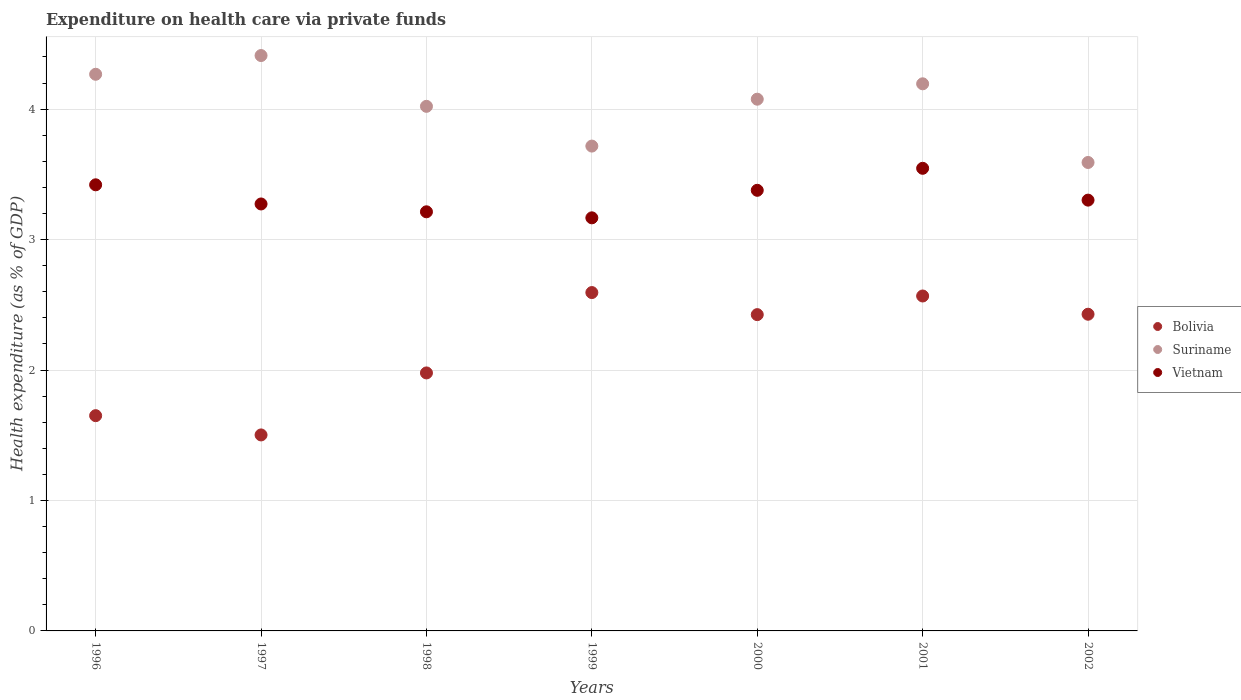How many different coloured dotlines are there?
Your response must be concise. 3. What is the expenditure made on health care in Suriname in 1999?
Your answer should be compact. 3.72. Across all years, what is the maximum expenditure made on health care in Vietnam?
Give a very brief answer. 3.55. Across all years, what is the minimum expenditure made on health care in Vietnam?
Give a very brief answer. 3.17. What is the total expenditure made on health care in Suriname in the graph?
Provide a succinct answer. 28.28. What is the difference between the expenditure made on health care in Vietnam in 1999 and that in 2000?
Offer a very short reply. -0.21. What is the difference between the expenditure made on health care in Vietnam in 2002 and the expenditure made on health care in Bolivia in 2001?
Ensure brevity in your answer.  0.73. What is the average expenditure made on health care in Suriname per year?
Provide a short and direct response. 4.04. In the year 2002, what is the difference between the expenditure made on health care in Bolivia and expenditure made on health care in Suriname?
Make the answer very short. -1.16. What is the ratio of the expenditure made on health care in Suriname in 2000 to that in 2001?
Make the answer very short. 0.97. Is the difference between the expenditure made on health care in Bolivia in 1996 and 2000 greater than the difference between the expenditure made on health care in Suriname in 1996 and 2000?
Your answer should be compact. No. What is the difference between the highest and the second highest expenditure made on health care in Bolivia?
Offer a very short reply. 0.03. What is the difference between the highest and the lowest expenditure made on health care in Bolivia?
Your answer should be very brief. 1.09. Is the sum of the expenditure made on health care in Bolivia in 2000 and 2001 greater than the maximum expenditure made on health care in Vietnam across all years?
Your answer should be compact. Yes. Does the expenditure made on health care in Suriname monotonically increase over the years?
Keep it short and to the point. No. How many dotlines are there?
Give a very brief answer. 3. How many years are there in the graph?
Give a very brief answer. 7. How are the legend labels stacked?
Ensure brevity in your answer.  Vertical. What is the title of the graph?
Provide a succinct answer. Expenditure on health care via private funds. What is the label or title of the Y-axis?
Your answer should be very brief. Health expenditure (as % of GDP). What is the Health expenditure (as % of GDP) in Bolivia in 1996?
Your answer should be compact. 1.65. What is the Health expenditure (as % of GDP) of Suriname in 1996?
Keep it short and to the point. 4.27. What is the Health expenditure (as % of GDP) in Vietnam in 1996?
Your answer should be very brief. 3.42. What is the Health expenditure (as % of GDP) of Bolivia in 1997?
Keep it short and to the point. 1.5. What is the Health expenditure (as % of GDP) of Suriname in 1997?
Offer a very short reply. 4.41. What is the Health expenditure (as % of GDP) of Vietnam in 1997?
Your answer should be compact. 3.27. What is the Health expenditure (as % of GDP) of Bolivia in 1998?
Your response must be concise. 1.98. What is the Health expenditure (as % of GDP) of Suriname in 1998?
Your answer should be very brief. 4.02. What is the Health expenditure (as % of GDP) in Vietnam in 1998?
Your response must be concise. 3.21. What is the Health expenditure (as % of GDP) of Bolivia in 1999?
Provide a succinct answer. 2.59. What is the Health expenditure (as % of GDP) of Suriname in 1999?
Ensure brevity in your answer.  3.72. What is the Health expenditure (as % of GDP) of Vietnam in 1999?
Give a very brief answer. 3.17. What is the Health expenditure (as % of GDP) in Bolivia in 2000?
Offer a very short reply. 2.42. What is the Health expenditure (as % of GDP) of Suriname in 2000?
Your answer should be compact. 4.08. What is the Health expenditure (as % of GDP) of Vietnam in 2000?
Make the answer very short. 3.38. What is the Health expenditure (as % of GDP) of Bolivia in 2001?
Offer a terse response. 2.57. What is the Health expenditure (as % of GDP) in Suriname in 2001?
Ensure brevity in your answer.  4.19. What is the Health expenditure (as % of GDP) in Vietnam in 2001?
Your answer should be compact. 3.55. What is the Health expenditure (as % of GDP) of Bolivia in 2002?
Your answer should be very brief. 2.43. What is the Health expenditure (as % of GDP) in Suriname in 2002?
Make the answer very short. 3.59. What is the Health expenditure (as % of GDP) of Vietnam in 2002?
Provide a succinct answer. 3.3. Across all years, what is the maximum Health expenditure (as % of GDP) in Bolivia?
Offer a very short reply. 2.59. Across all years, what is the maximum Health expenditure (as % of GDP) of Suriname?
Make the answer very short. 4.41. Across all years, what is the maximum Health expenditure (as % of GDP) of Vietnam?
Your response must be concise. 3.55. Across all years, what is the minimum Health expenditure (as % of GDP) of Bolivia?
Provide a succinct answer. 1.5. Across all years, what is the minimum Health expenditure (as % of GDP) of Suriname?
Provide a succinct answer. 3.59. Across all years, what is the minimum Health expenditure (as % of GDP) of Vietnam?
Your answer should be compact. 3.17. What is the total Health expenditure (as % of GDP) in Bolivia in the graph?
Keep it short and to the point. 15.14. What is the total Health expenditure (as % of GDP) in Suriname in the graph?
Offer a terse response. 28.28. What is the total Health expenditure (as % of GDP) in Vietnam in the graph?
Your answer should be compact. 23.3. What is the difference between the Health expenditure (as % of GDP) in Bolivia in 1996 and that in 1997?
Your answer should be very brief. 0.15. What is the difference between the Health expenditure (as % of GDP) in Suriname in 1996 and that in 1997?
Offer a terse response. -0.14. What is the difference between the Health expenditure (as % of GDP) of Vietnam in 1996 and that in 1997?
Your answer should be very brief. 0.15. What is the difference between the Health expenditure (as % of GDP) of Bolivia in 1996 and that in 1998?
Your answer should be very brief. -0.33. What is the difference between the Health expenditure (as % of GDP) of Suriname in 1996 and that in 1998?
Ensure brevity in your answer.  0.25. What is the difference between the Health expenditure (as % of GDP) of Vietnam in 1996 and that in 1998?
Ensure brevity in your answer.  0.21. What is the difference between the Health expenditure (as % of GDP) of Bolivia in 1996 and that in 1999?
Provide a short and direct response. -0.94. What is the difference between the Health expenditure (as % of GDP) in Suriname in 1996 and that in 1999?
Offer a very short reply. 0.55. What is the difference between the Health expenditure (as % of GDP) of Vietnam in 1996 and that in 1999?
Your answer should be compact. 0.25. What is the difference between the Health expenditure (as % of GDP) in Bolivia in 1996 and that in 2000?
Your response must be concise. -0.77. What is the difference between the Health expenditure (as % of GDP) of Suriname in 1996 and that in 2000?
Your response must be concise. 0.19. What is the difference between the Health expenditure (as % of GDP) in Vietnam in 1996 and that in 2000?
Make the answer very short. 0.04. What is the difference between the Health expenditure (as % of GDP) of Bolivia in 1996 and that in 2001?
Provide a succinct answer. -0.92. What is the difference between the Health expenditure (as % of GDP) in Suriname in 1996 and that in 2001?
Offer a terse response. 0.07. What is the difference between the Health expenditure (as % of GDP) of Vietnam in 1996 and that in 2001?
Provide a short and direct response. -0.13. What is the difference between the Health expenditure (as % of GDP) in Bolivia in 1996 and that in 2002?
Provide a short and direct response. -0.78. What is the difference between the Health expenditure (as % of GDP) of Suriname in 1996 and that in 2002?
Your response must be concise. 0.68. What is the difference between the Health expenditure (as % of GDP) of Vietnam in 1996 and that in 2002?
Keep it short and to the point. 0.12. What is the difference between the Health expenditure (as % of GDP) in Bolivia in 1997 and that in 1998?
Make the answer very short. -0.48. What is the difference between the Health expenditure (as % of GDP) of Suriname in 1997 and that in 1998?
Offer a terse response. 0.39. What is the difference between the Health expenditure (as % of GDP) in Vietnam in 1997 and that in 1998?
Offer a very short reply. 0.06. What is the difference between the Health expenditure (as % of GDP) of Bolivia in 1997 and that in 1999?
Provide a short and direct response. -1.09. What is the difference between the Health expenditure (as % of GDP) in Suriname in 1997 and that in 1999?
Provide a short and direct response. 0.69. What is the difference between the Health expenditure (as % of GDP) of Vietnam in 1997 and that in 1999?
Your response must be concise. 0.11. What is the difference between the Health expenditure (as % of GDP) of Bolivia in 1997 and that in 2000?
Your response must be concise. -0.92. What is the difference between the Health expenditure (as % of GDP) of Suriname in 1997 and that in 2000?
Ensure brevity in your answer.  0.33. What is the difference between the Health expenditure (as % of GDP) in Vietnam in 1997 and that in 2000?
Your response must be concise. -0.1. What is the difference between the Health expenditure (as % of GDP) of Bolivia in 1997 and that in 2001?
Your response must be concise. -1.07. What is the difference between the Health expenditure (as % of GDP) of Suriname in 1997 and that in 2001?
Give a very brief answer. 0.22. What is the difference between the Health expenditure (as % of GDP) of Vietnam in 1997 and that in 2001?
Your answer should be compact. -0.27. What is the difference between the Health expenditure (as % of GDP) of Bolivia in 1997 and that in 2002?
Ensure brevity in your answer.  -0.93. What is the difference between the Health expenditure (as % of GDP) of Suriname in 1997 and that in 2002?
Your answer should be compact. 0.82. What is the difference between the Health expenditure (as % of GDP) of Vietnam in 1997 and that in 2002?
Your answer should be compact. -0.03. What is the difference between the Health expenditure (as % of GDP) of Bolivia in 1998 and that in 1999?
Keep it short and to the point. -0.62. What is the difference between the Health expenditure (as % of GDP) of Suriname in 1998 and that in 1999?
Give a very brief answer. 0.3. What is the difference between the Health expenditure (as % of GDP) in Vietnam in 1998 and that in 1999?
Ensure brevity in your answer.  0.05. What is the difference between the Health expenditure (as % of GDP) in Bolivia in 1998 and that in 2000?
Offer a terse response. -0.45. What is the difference between the Health expenditure (as % of GDP) in Suriname in 1998 and that in 2000?
Ensure brevity in your answer.  -0.05. What is the difference between the Health expenditure (as % of GDP) in Vietnam in 1998 and that in 2000?
Provide a succinct answer. -0.16. What is the difference between the Health expenditure (as % of GDP) in Bolivia in 1998 and that in 2001?
Give a very brief answer. -0.59. What is the difference between the Health expenditure (as % of GDP) in Suriname in 1998 and that in 2001?
Provide a short and direct response. -0.17. What is the difference between the Health expenditure (as % of GDP) of Vietnam in 1998 and that in 2001?
Provide a short and direct response. -0.33. What is the difference between the Health expenditure (as % of GDP) of Bolivia in 1998 and that in 2002?
Your answer should be very brief. -0.45. What is the difference between the Health expenditure (as % of GDP) of Suriname in 1998 and that in 2002?
Provide a succinct answer. 0.43. What is the difference between the Health expenditure (as % of GDP) in Vietnam in 1998 and that in 2002?
Offer a very short reply. -0.09. What is the difference between the Health expenditure (as % of GDP) of Bolivia in 1999 and that in 2000?
Your response must be concise. 0.17. What is the difference between the Health expenditure (as % of GDP) in Suriname in 1999 and that in 2000?
Offer a very short reply. -0.36. What is the difference between the Health expenditure (as % of GDP) in Vietnam in 1999 and that in 2000?
Your response must be concise. -0.21. What is the difference between the Health expenditure (as % of GDP) in Bolivia in 1999 and that in 2001?
Give a very brief answer. 0.03. What is the difference between the Health expenditure (as % of GDP) of Suriname in 1999 and that in 2001?
Provide a short and direct response. -0.48. What is the difference between the Health expenditure (as % of GDP) in Vietnam in 1999 and that in 2001?
Provide a succinct answer. -0.38. What is the difference between the Health expenditure (as % of GDP) of Bolivia in 1999 and that in 2002?
Ensure brevity in your answer.  0.17. What is the difference between the Health expenditure (as % of GDP) in Suriname in 1999 and that in 2002?
Ensure brevity in your answer.  0.13. What is the difference between the Health expenditure (as % of GDP) in Vietnam in 1999 and that in 2002?
Provide a succinct answer. -0.14. What is the difference between the Health expenditure (as % of GDP) of Bolivia in 2000 and that in 2001?
Your answer should be compact. -0.14. What is the difference between the Health expenditure (as % of GDP) of Suriname in 2000 and that in 2001?
Your answer should be very brief. -0.12. What is the difference between the Health expenditure (as % of GDP) of Vietnam in 2000 and that in 2001?
Provide a succinct answer. -0.17. What is the difference between the Health expenditure (as % of GDP) in Bolivia in 2000 and that in 2002?
Provide a short and direct response. -0. What is the difference between the Health expenditure (as % of GDP) in Suriname in 2000 and that in 2002?
Your answer should be compact. 0.49. What is the difference between the Health expenditure (as % of GDP) of Vietnam in 2000 and that in 2002?
Provide a short and direct response. 0.08. What is the difference between the Health expenditure (as % of GDP) in Bolivia in 2001 and that in 2002?
Give a very brief answer. 0.14. What is the difference between the Health expenditure (as % of GDP) in Suriname in 2001 and that in 2002?
Your response must be concise. 0.6. What is the difference between the Health expenditure (as % of GDP) of Vietnam in 2001 and that in 2002?
Make the answer very short. 0.24. What is the difference between the Health expenditure (as % of GDP) in Bolivia in 1996 and the Health expenditure (as % of GDP) in Suriname in 1997?
Your answer should be compact. -2.76. What is the difference between the Health expenditure (as % of GDP) in Bolivia in 1996 and the Health expenditure (as % of GDP) in Vietnam in 1997?
Ensure brevity in your answer.  -1.62. What is the difference between the Health expenditure (as % of GDP) of Suriname in 1996 and the Health expenditure (as % of GDP) of Vietnam in 1997?
Provide a succinct answer. 0.99. What is the difference between the Health expenditure (as % of GDP) in Bolivia in 1996 and the Health expenditure (as % of GDP) in Suriname in 1998?
Make the answer very short. -2.37. What is the difference between the Health expenditure (as % of GDP) in Bolivia in 1996 and the Health expenditure (as % of GDP) in Vietnam in 1998?
Keep it short and to the point. -1.56. What is the difference between the Health expenditure (as % of GDP) of Suriname in 1996 and the Health expenditure (as % of GDP) of Vietnam in 1998?
Make the answer very short. 1.05. What is the difference between the Health expenditure (as % of GDP) of Bolivia in 1996 and the Health expenditure (as % of GDP) of Suriname in 1999?
Your response must be concise. -2.07. What is the difference between the Health expenditure (as % of GDP) in Bolivia in 1996 and the Health expenditure (as % of GDP) in Vietnam in 1999?
Make the answer very short. -1.52. What is the difference between the Health expenditure (as % of GDP) of Suriname in 1996 and the Health expenditure (as % of GDP) of Vietnam in 1999?
Your answer should be very brief. 1.1. What is the difference between the Health expenditure (as % of GDP) of Bolivia in 1996 and the Health expenditure (as % of GDP) of Suriname in 2000?
Your response must be concise. -2.43. What is the difference between the Health expenditure (as % of GDP) in Bolivia in 1996 and the Health expenditure (as % of GDP) in Vietnam in 2000?
Provide a succinct answer. -1.73. What is the difference between the Health expenditure (as % of GDP) in Suriname in 1996 and the Health expenditure (as % of GDP) in Vietnam in 2000?
Give a very brief answer. 0.89. What is the difference between the Health expenditure (as % of GDP) in Bolivia in 1996 and the Health expenditure (as % of GDP) in Suriname in 2001?
Provide a succinct answer. -2.54. What is the difference between the Health expenditure (as % of GDP) of Bolivia in 1996 and the Health expenditure (as % of GDP) of Vietnam in 2001?
Ensure brevity in your answer.  -1.9. What is the difference between the Health expenditure (as % of GDP) of Suriname in 1996 and the Health expenditure (as % of GDP) of Vietnam in 2001?
Your response must be concise. 0.72. What is the difference between the Health expenditure (as % of GDP) of Bolivia in 1996 and the Health expenditure (as % of GDP) of Suriname in 2002?
Ensure brevity in your answer.  -1.94. What is the difference between the Health expenditure (as % of GDP) of Bolivia in 1996 and the Health expenditure (as % of GDP) of Vietnam in 2002?
Your response must be concise. -1.65. What is the difference between the Health expenditure (as % of GDP) of Suriname in 1996 and the Health expenditure (as % of GDP) of Vietnam in 2002?
Offer a terse response. 0.96. What is the difference between the Health expenditure (as % of GDP) of Bolivia in 1997 and the Health expenditure (as % of GDP) of Suriname in 1998?
Provide a succinct answer. -2.52. What is the difference between the Health expenditure (as % of GDP) in Bolivia in 1997 and the Health expenditure (as % of GDP) in Vietnam in 1998?
Give a very brief answer. -1.71. What is the difference between the Health expenditure (as % of GDP) of Suriname in 1997 and the Health expenditure (as % of GDP) of Vietnam in 1998?
Keep it short and to the point. 1.2. What is the difference between the Health expenditure (as % of GDP) in Bolivia in 1997 and the Health expenditure (as % of GDP) in Suriname in 1999?
Offer a very short reply. -2.21. What is the difference between the Health expenditure (as % of GDP) of Bolivia in 1997 and the Health expenditure (as % of GDP) of Vietnam in 1999?
Provide a short and direct response. -1.66. What is the difference between the Health expenditure (as % of GDP) of Suriname in 1997 and the Health expenditure (as % of GDP) of Vietnam in 1999?
Your answer should be compact. 1.24. What is the difference between the Health expenditure (as % of GDP) in Bolivia in 1997 and the Health expenditure (as % of GDP) in Suriname in 2000?
Your answer should be very brief. -2.57. What is the difference between the Health expenditure (as % of GDP) in Bolivia in 1997 and the Health expenditure (as % of GDP) in Vietnam in 2000?
Your answer should be compact. -1.88. What is the difference between the Health expenditure (as % of GDP) in Suriname in 1997 and the Health expenditure (as % of GDP) in Vietnam in 2000?
Your answer should be compact. 1.03. What is the difference between the Health expenditure (as % of GDP) in Bolivia in 1997 and the Health expenditure (as % of GDP) in Suriname in 2001?
Provide a succinct answer. -2.69. What is the difference between the Health expenditure (as % of GDP) of Bolivia in 1997 and the Health expenditure (as % of GDP) of Vietnam in 2001?
Provide a short and direct response. -2.04. What is the difference between the Health expenditure (as % of GDP) in Suriname in 1997 and the Health expenditure (as % of GDP) in Vietnam in 2001?
Offer a terse response. 0.86. What is the difference between the Health expenditure (as % of GDP) of Bolivia in 1997 and the Health expenditure (as % of GDP) of Suriname in 2002?
Give a very brief answer. -2.09. What is the difference between the Health expenditure (as % of GDP) in Bolivia in 1997 and the Health expenditure (as % of GDP) in Vietnam in 2002?
Your answer should be very brief. -1.8. What is the difference between the Health expenditure (as % of GDP) of Suriname in 1997 and the Health expenditure (as % of GDP) of Vietnam in 2002?
Keep it short and to the point. 1.11. What is the difference between the Health expenditure (as % of GDP) in Bolivia in 1998 and the Health expenditure (as % of GDP) in Suriname in 1999?
Offer a very short reply. -1.74. What is the difference between the Health expenditure (as % of GDP) in Bolivia in 1998 and the Health expenditure (as % of GDP) in Vietnam in 1999?
Your response must be concise. -1.19. What is the difference between the Health expenditure (as % of GDP) in Suriname in 1998 and the Health expenditure (as % of GDP) in Vietnam in 1999?
Ensure brevity in your answer.  0.85. What is the difference between the Health expenditure (as % of GDP) of Bolivia in 1998 and the Health expenditure (as % of GDP) of Suriname in 2000?
Make the answer very short. -2.1. What is the difference between the Health expenditure (as % of GDP) of Bolivia in 1998 and the Health expenditure (as % of GDP) of Vietnam in 2000?
Keep it short and to the point. -1.4. What is the difference between the Health expenditure (as % of GDP) in Suriname in 1998 and the Health expenditure (as % of GDP) in Vietnam in 2000?
Your response must be concise. 0.64. What is the difference between the Health expenditure (as % of GDP) of Bolivia in 1998 and the Health expenditure (as % of GDP) of Suriname in 2001?
Keep it short and to the point. -2.22. What is the difference between the Health expenditure (as % of GDP) of Bolivia in 1998 and the Health expenditure (as % of GDP) of Vietnam in 2001?
Provide a short and direct response. -1.57. What is the difference between the Health expenditure (as % of GDP) of Suriname in 1998 and the Health expenditure (as % of GDP) of Vietnam in 2001?
Your response must be concise. 0.48. What is the difference between the Health expenditure (as % of GDP) of Bolivia in 1998 and the Health expenditure (as % of GDP) of Suriname in 2002?
Ensure brevity in your answer.  -1.61. What is the difference between the Health expenditure (as % of GDP) in Bolivia in 1998 and the Health expenditure (as % of GDP) in Vietnam in 2002?
Provide a succinct answer. -1.32. What is the difference between the Health expenditure (as % of GDP) of Suriname in 1998 and the Health expenditure (as % of GDP) of Vietnam in 2002?
Offer a very short reply. 0.72. What is the difference between the Health expenditure (as % of GDP) in Bolivia in 1999 and the Health expenditure (as % of GDP) in Suriname in 2000?
Your answer should be compact. -1.48. What is the difference between the Health expenditure (as % of GDP) of Bolivia in 1999 and the Health expenditure (as % of GDP) of Vietnam in 2000?
Give a very brief answer. -0.78. What is the difference between the Health expenditure (as % of GDP) in Suriname in 1999 and the Health expenditure (as % of GDP) in Vietnam in 2000?
Your answer should be compact. 0.34. What is the difference between the Health expenditure (as % of GDP) in Bolivia in 1999 and the Health expenditure (as % of GDP) in Suriname in 2001?
Give a very brief answer. -1.6. What is the difference between the Health expenditure (as % of GDP) of Bolivia in 1999 and the Health expenditure (as % of GDP) of Vietnam in 2001?
Offer a terse response. -0.95. What is the difference between the Health expenditure (as % of GDP) of Suriname in 1999 and the Health expenditure (as % of GDP) of Vietnam in 2001?
Make the answer very short. 0.17. What is the difference between the Health expenditure (as % of GDP) in Bolivia in 1999 and the Health expenditure (as % of GDP) in Suriname in 2002?
Give a very brief answer. -1. What is the difference between the Health expenditure (as % of GDP) of Bolivia in 1999 and the Health expenditure (as % of GDP) of Vietnam in 2002?
Offer a very short reply. -0.71. What is the difference between the Health expenditure (as % of GDP) of Suriname in 1999 and the Health expenditure (as % of GDP) of Vietnam in 2002?
Your answer should be very brief. 0.41. What is the difference between the Health expenditure (as % of GDP) in Bolivia in 2000 and the Health expenditure (as % of GDP) in Suriname in 2001?
Keep it short and to the point. -1.77. What is the difference between the Health expenditure (as % of GDP) of Bolivia in 2000 and the Health expenditure (as % of GDP) of Vietnam in 2001?
Your response must be concise. -1.12. What is the difference between the Health expenditure (as % of GDP) in Suriname in 2000 and the Health expenditure (as % of GDP) in Vietnam in 2001?
Your response must be concise. 0.53. What is the difference between the Health expenditure (as % of GDP) of Bolivia in 2000 and the Health expenditure (as % of GDP) of Suriname in 2002?
Your response must be concise. -1.17. What is the difference between the Health expenditure (as % of GDP) in Bolivia in 2000 and the Health expenditure (as % of GDP) in Vietnam in 2002?
Offer a terse response. -0.88. What is the difference between the Health expenditure (as % of GDP) of Suriname in 2000 and the Health expenditure (as % of GDP) of Vietnam in 2002?
Give a very brief answer. 0.77. What is the difference between the Health expenditure (as % of GDP) of Bolivia in 2001 and the Health expenditure (as % of GDP) of Suriname in 2002?
Your response must be concise. -1.02. What is the difference between the Health expenditure (as % of GDP) of Bolivia in 2001 and the Health expenditure (as % of GDP) of Vietnam in 2002?
Ensure brevity in your answer.  -0.73. What is the difference between the Health expenditure (as % of GDP) of Suriname in 2001 and the Health expenditure (as % of GDP) of Vietnam in 2002?
Your answer should be very brief. 0.89. What is the average Health expenditure (as % of GDP) of Bolivia per year?
Your answer should be very brief. 2.16. What is the average Health expenditure (as % of GDP) in Suriname per year?
Your answer should be compact. 4.04. What is the average Health expenditure (as % of GDP) in Vietnam per year?
Provide a succinct answer. 3.33. In the year 1996, what is the difference between the Health expenditure (as % of GDP) of Bolivia and Health expenditure (as % of GDP) of Suriname?
Provide a succinct answer. -2.62. In the year 1996, what is the difference between the Health expenditure (as % of GDP) of Bolivia and Health expenditure (as % of GDP) of Vietnam?
Offer a terse response. -1.77. In the year 1996, what is the difference between the Health expenditure (as % of GDP) in Suriname and Health expenditure (as % of GDP) in Vietnam?
Ensure brevity in your answer.  0.85. In the year 1997, what is the difference between the Health expenditure (as % of GDP) of Bolivia and Health expenditure (as % of GDP) of Suriname?
Make the answer very short. -2.91. In the year 1997, what is the difference between the Health expenditure (as % of GDP) in Bolivia and Health expenditure (as % of GDP) in Vietnam?
Give a very brief answer. -1.77. In the year 1997, what is the difference between the Health expenditure (as % of GDP) in Suriname and Health expenditure (as % of GDP) in Vietnam?
Give a very brief answer. 1.14. In the year 1998, what is the difference between the Health expenditure (as % of GDP) in Bolivia and Health expenditure (as % of GDP) in Suriname?
Ensure brevity in your answer.  -2.04. In the year 1998, what is the difference between the Health expenditure (as % of GDP) of Bolivia and Health expenditure (as % of GDP) of Vietnam?
Provide a succinct answer. -1.24. In the year 1998, what is the difference between the Health expenditure (as % of GDP) of Suriname and Health expenditure (as % of GDP) of Vietnam?
Offer a terse response. 0.81. In the year 1999, what is the difference between the Health expenditure (as % of GDP) in Bolivia and Health expenditure (as % of GDP) in Suriname?
Offer a terse response. -1.12. In the year 1999, what is the difference between the Health expenditure (as % of GDP) in Bolivia and Health expenditure (as % of GDP) in Vietnam?
Your answer should be compact. -0.57. In the year 1999, what is the difference between the Health expenditure (as % of GDP) in Suriname and Health expenditure (as % of GDP) in Vietnam?
Offer a very short reply. 0.55. In the year 2000, what is the difference between the Health expenditure (as % of GDP) in Bolivia and Health expenditure (as % of GDP) in Suriname?
Ensure brevity in your answer.  -1.65. In the year 2000, what is the difference between the Health expenditure (as % of GDP) in Bolivia and Health expenditure (as % of GDP) in Vietnam?
Provide a short and direct response. -0.95. In the year 2000, what is the difference between the Health expenditure (as % of GDP) in Suriname and Health expenditure (as % of GDP) in Vietnam?
Provide a short and direct response. 0.7. In the year 2001, what is the difference between the Health expenditure (as % of GDP) of Bolivia and Health expenditure (as % of GDP) of Suriname?
Offer a very short reply. -1.63. In the year 2001, what is the difference between the Health expenditure (as % of GDP) in Bolivia and Health expenditure (as % of GDP) in Vietnam?
Your response must be concise. -0.98. In the year 2001, what is the difference between the Health expenditure (as % of GDP) of Suriname and Health expenditure (as % of GDP) of Vietnam?
Your answer should be compact. 0.65. In the year 2002, what is the difference between the Health expenditure (as % of GDP) in Bolivia and Health expenditure (as % of GDP) in Suriname?
Ensure brevity in your answer.  -1.16. In the year 2002, what is the difference between the Health expenditure (as % of GDP) in Bolivia and Health expenditure (as % of GDP) in Vietnam?
Offer a terse response. -0.87. In the year 2002, what is the difference between the Health expenditure (as % of GDP) of Suriname and Health expenditure (as % of GDP) of Vietnam?
Your answer should be very brief. 0.29. What is the ratio of the Health expenditure (as % of GDP) in Bolivia in 1996 to that in 1997?
Provide a succinct answer. 1.1. What is the ratio of the Health expenditure (as % of GDP) in Suriname in 1996 to that in 1997?
Offer a very short reply. 0.97. What is the ratio of the Health expenditure (as % of GDP) of Vietnam in 1996 to that in 1997?
Provide a short and direct response. 1.04. What is the ratio of the Health expenditure (as % of GDP) of Bolivia in 1996 to that in 1998?
Give a very brief answer. 0.83. What is the ratio of the Health expenditure (as % of GDP) of Suriname in 1996 to that in 1998?
Keep it short and to the point. 1.06. What is the ratio of the Health expenditure (as % of GDP) of Vietnam in 1996 to that in 1998?
Your answer should be compact. 1.06. What is the ratio of the Health expenditure (as % of GDP) in Bolivia in 1996 to that in 1999?
Ensure brevity in your answer.  0.64. What is the ratio of the Health expenditure (as % of GDP) of Suriname in 1996 to that in 1999?
Offer a terse response. 1.15. What is the ratio of the Health expenditure (as % of GDP) in Vietnam in 1996 to that in 1999?
Your answer should be compact. 1.08. What is the ratio of the Health expenditure (as % of GDP) of Bolivia in 1996 to that in 2000?
Provide a short and direct response. 0.68. What is the ratio of the Health expenditure (as % of GDP) of Suriname in 1996 to that in 2000?
Give a very brief answer. 1.05. What is the ratio of the Health expenditure (as % of GDP) of Vietnam in 1996 to that in 2000?
Your response must be concise. 1.01. What is the ratio of the Health expenditure (as % of GDP) of Bolivia in 1996 to that in 2001?
Provide a succinct answer. 0.64. What is the ratio of the Health expenditure (as % of GDP) of Suriname in 1996 to that in 2001?
Offer a very short reply. 1.02. What is the ratio of the Health expenditure (as % of GDP) in Bolivia in 1996 to that in 2002?
Provide a succinct answer. 0.68. What is the ratio of the Health expenditure (as % of GDP) in Suriname in 1996 to that in 2002?
Keep it short and to the point. 1.19. What is the ratio of the Health expenditure (as % of GDP) of Vietnam in 1996 to that in 2002?
Your response must be concise. 1.04. What is the ratio of the Health expenditure (as % of GDP) of Bolivia in 1997 to that in 1998?
Provide a short and direct response. 0.76. What is the ratio of the Health expenditure (as % of GDP) in Suriname in 1997 to that in 1998?
Make the answer very short. 1.1. What is the ratio of the Health expenditure (as % of GDP) of Vietnam in 1997 to that in 1998?
Give a very brief answer. 1.02. What is the ratio of the Health expenditure (as % of GDP) of Bolivia in 1997 to that in 1999?
Offer a terse response. 0.58. What is the ratio of the Health expenditure (as % of GDP) of Suriname in 1997 to that in 1999?
Offer a very short reply. 1.19. What is the ratio of the Health expenditure (as % of GDP) in Vietnam in 1997 to that in 1999?
Provide a succinct answer. 1.03. What is the ratio of the Health expenditure (as % of GDP) of Bolivia in 1997 to that in 2000?
Your answer should be very brief. 0.62. What is the ratio of the Health expenditure (as % of GDP) in Suriname in 1997 to that in 2000?
Provide a succinct answer. 1.08. What is the ratio of the Health expenditure (as % of GDP) of Vietnam in 1997 to that in 2000?
Offer a terse response. 0.97. What is the ratio of the Health expenditure (as % of GDP) of Bolivia in 1997 to that in 2001?
Ensure brevity in your answer.  0.59. What is the ratio of the Health expenditure (as % of GDP) in Suriname in 1997 to that in 2001?
Make the answer very short. 1.05. What is the ratio of the Health expenditure (as % of GDP) in Vietnam in 1997 to that in 2001?
Provide a succinct answer. 0.92. What is the ratio of the Health expenditure (as % of GDP) in Bolivia in 1997 to that in 2002?
Your answer should be compact. 0.62. What is the ratio of the Health expenditure (as % of GDP) of Suriname in 1997 to that in 2002?
Your response must be concise. 1.23. What is the ratio of the Health expenditure (as % of GDP) in Bolivia in 1998 to that in 1999?
Offer a terse response. 0.76. What is the ratio of the Health expenditure (as % of GDP) of Suriname in 1998 to that in 1999?
Provide a short and direct response. 1.08. What is the ratio of the Health expenditure (as % of GDP) in Vietnam in 1998 to that in 1999?
Make the answer very short. 1.01. What is the ratio of the Health expenditure (as % of GDP) of Bolivia in 1998 to that in 2000?
Your answer should be compact. 0.82. What is the ratio of the Health expenditure (as % of GDP) of Suriname in 1998 to that in 2000?
Offer a terse response. 0.99. What is the ratio of the Health expenditure (as % of GDP) in Vietnam in 1998 to that in 2000?
Make the answer very short. 0.95. What is the ratio of the Health expenditure (as % of GDP) of Bolivia in 1998 to that in 2001?
Provide a short and direct response. 0.77. What is the ratio of the Health expenditure (as % of GDP) in Suriname in 1998 to that in 2001?
Ensure brevity in your answer.  0.96. What is the ratio of the Health expenditure (as % of GDP) of Vietnam in 1998 to that in 2001?
Keep it short and to the point. 0.91. What is the ratio of the Health expenditure (as % of GDP) of Bolivia in 1998 to that in 2002?
Your answer should be very brief. 0.81. What is the ratio of the Health expenditure (as % of GDP) in Suriname in 1998 to that in 2002?
Your response must be concise. 1.12. What is the ratio of the Health expenditure (as % of GDP) in Vietnam in 1998 to that in 2002?
Provide a short and direct response. 0.97. What is the ratio of the Health expenditure (as % of GDP) in Bolivia in 1999 to that in 2000?
Ensure brevity in your answer.  1.07. What is the ratio of the Health expenditure (as % of GDP) in Suriname in 1999 to that in 2000?
Provide a short and direct response. 0.91. What is the ratio of the Health expenditure (as % of GDP) in Bolivia in 1999 to that in 2001?
Provide a short and direct response. 1.01. What is the ratio of the Health expenditure (as % of GDP) in Suriname in 1999 to that in 2001?
Ensure brevity in your answer.  0.89. What is the ratio of the Health expenditure (as % of GDP) in Vietnam in 1999 to that in 2001?
Your answer should be compact. 0.89. What is the ratio of the Health expenditure (as % of GDP) in Bolivia in 1999 to that in 2002?
Offer a terse response. 1.07. What is the ratio of the Health expenditure (as % of GDP) of Suriname in 1999 to that in 2002?
Your answer should be compact. 1.03. What is the ratio of the Health expenditure (as % of GDP) of Vietnam in 1999 to that in 2002?
Provide a succinct answer. 0.96. What is the ratio of the Health expenditure (as % of GDP) in Bolivia in 2000 to that in 2001?
Provide a short and direct response. 0.94. What is the ratio of the Health expenditure (as % of GDP) in Suriname in 2000 to that in 2001?
Make the answer very short. 0.97. What is the ratio of the Health expenditure (as % of GDP) in Vietnam in 2000 to that in 2001?
Provide a succinct answer. 0.95. What is the ratio of the Health expenditure (as % of GDP) in Suriname in 2000 to that in 2002?
Your answer should be compact. 1.14. What is the ratio of the Health expenditure (as % of GDP) in Vietnam in 2000 to that in 2002?
Your response must be concise. 1.02. What is the ratio of the Health expenditure (as % of GDP) in Bolivia in 2001 to that in 2002?
Your response must be concise. 1.06. What is the ratio of the Health expenditure (as % of GDP) in Suriname in 2001 to that in 2002?
Offer a very short reply. 1.17. What is the ratio of the Health expenditure (as % of GDP) in Vietnam in 2001 to that in 2002?
Your answer should be compact. 1.07. What is the difference between the highest and the second highest Health expenditure (as % of GDP) of Bolivia?
Keep it short and to the point. 0.03. What is the difference between the highest and the second highest Health expenditure (as % of GDP) in Suriname?
Provide a short and direct response. 0.14. What is the difference between the highest and the second highest Health expenditure (as % of GDP) of Vietnam?
Ensure brevity in your answer.  0.13. What is the difference between the highest and the lowest Health expenditure (as % of GDP) in Bolivia?
Ensure brevity in your answer.  1.09. What is the difference between the highest and the lowest Health expenditure (as % of GDP) of Suriname?
Your response must be concise. 0.82. What is the difference between the highest and the lowest Health expenditure (as % of GDP) of Vietnam?
Give a very brief answer. 0.38. 